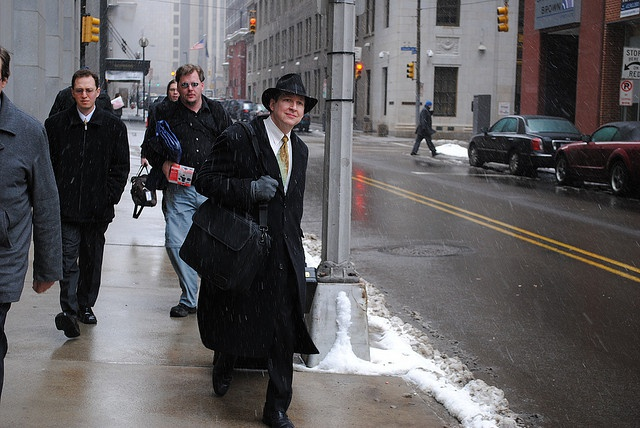Describe the objects in this image and their specific colors. I can see people in gray, black, darkgray, and brown tones, people in gray, black, and darkgray tones, people in gray and black tones, people in gray, black, and darkgray tones, and handbag in gray and black tones in this image. 